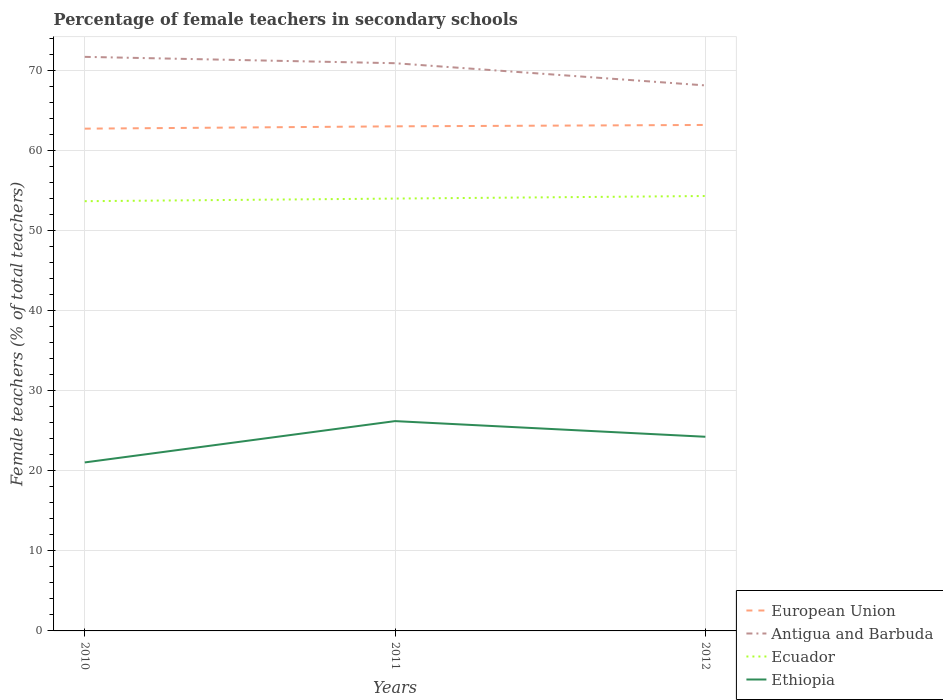Across all years, what is the maximum percentage of female teachers in Ecuador?
Make the answer very short. 53.72. In which year was the percentage of female teachers in Ecuador maximum?
Your answer should be compact. 2010. What is the total percentage of female teachers in Antigua and Barbuda in the graph?
Your answer should be very brief. 3.57. What is the difference between the highest and the second highest percentage of female teachers in European Union?
Offer a terse response. 0.46. What is the difference between the highest and the lowest percentage of female teachers in Ethiopia?
Your answer should be compact. 2. Is the percentage of female teachers in Antigua and Barbuda strictly greater than the percentage of female teachers in European Union over the years?
Ensure brevity in your answer.  No. Does the graph contain grids?
Offer a very short reply. Yes. Where does the legend appear in the graph?
Offer a very short reply. Bottom right. How many legend labels are there?
Offer a very short reply. 4. How are the legend labels stacked?
Keep it short and to the point. Vertical. What is the title of the graph?
Give a very brief answer. Percentage of female teachers in secondary schools. What is the label or title of the Y-axis?
Offer a terse response. Female teachers (% of total teachers). What is the Female teachers (% of total teachers) in European Union in 2010?
Make the answer very short. 62.78. What is the Female teachers (% of total teachers) of Antigua and Barbuda in 2010?
Give a very brief answer. 71.76. What is the Female teachers (% of total teachers) of Ecuador in 2010?
Your answer should be very brief. 53.72. What is the Female teachers (% of total teachers) of Ethiopia in 2010?
Ensure brevity in your answer.  21.06. What is the Female teachers (% of total teachers) in European Union in 2011?
Ensure brevity in your answer.  63.07. What is the Female teachers (% of total teachers) of Antigua and Barbuda in 2011?
Provide a succinct answer. 70.96. What is the Female teachers (% of total teachers) in Ecuador in 2011?
Your answer should be very brief. 54.04. What is the Female teachers (% of total teachers) of Ethiopia in 2011?
Make the answer very short. 26.23. What is the Female teachers (% of total teachers) in European Union in 2012?
Your answer should be very brief. 63.25. What is the Female teachers (% of total teachers) in Antigua and Barbuda in 2012?
Keep it short and to the point. 68.19. What is the Female teachers (% of total teachers) in Ecuador in 2012?
Offer a terse response. 54.36. What is the Female teachers (% of total teachers) in Ethiopia in 2012?
Ensure brevity in your answer.  24.27. Across all years, what is the maximum Female teachers (% of total teachers) of European Union?
Your answer should be very brief. 63.25. Across all years, what is the maximum Female teachers (% of total teachers) of Antigua and Barbuda?
Your answer should be very brief. 71.76. Across all years, what is the maximum Female teachers (% of total teachers) of Ecuador?
Offer a very short reply. 54.36. Across all years, what is the maximum Female teachers (% of total teachers) in Ethiopia?
Ensure brevity in your answer.  26.23. Across all years, what is the minimum Female teachers (% of total teachers) of European Union?
Offer a terse response. 62.78. Across all years, what is the minimum Female teachers (% of total teachers) in Antigua and Barbuda?
Ensure brevity in your answer.  68.19. Across all years, what is the minimum Female teachers (% of total teachers) of Ecuador?
Give a very brief answer. 53.72. Across all years, what is the minimum Female teachers (% of total teachers) in Ethiopia?
Your answer should be very brief. 21.06. What is the total Female teachers (% of total teachers) in European Union in the graph?
Your answer should be compact. 189.1. What is the total Female teachers (% of total teachers) in Antigua and Barbuda in the graph?
Make the answer very short. 210.91. What is the total Female teachers (% of total teachers) in Ecuador in the graph?
Your answer should be very brief. 162.12. What is the total Female teachers (% of total teachers) in Ethiopia in the graph?
Provide a short and direct response. 71.56. What is the difference between the Female teachers (% of total teachers) of European Union in 2010 and that in 2011?
Your answer should be compact. -0.29. What is the difference between the Female teachers (% of total teachers) of Antigua and Barbuda in 2010 and that in 2011?
Your answer should be compact. 0.79. What is the difference between the Female teachers (% of total teachers) in Ecuador in 2010 and that in 2011?
Your response must be concise. -0.33. What is the difference between the Female teachers (% of total teachers) of Ethiopia in 2010 and that in 2011?
Offer a terse response. -5.17. What is the difference between the Female teachers (% of total teachers) in European Union in 2010 and that in 2012?
Offer a terse response. -0.46. What is the difference between the Female teachers (% of total teachers) of Antigua and Barbuda in 2010 and that in 2012?
Your answer should be compact. 3.57. What is the difference between the Female teachers (% of total teachers) in Ecuador in 2010 and that in 2012?
Provide a succinct answer. -0.65. What is the difference between the Female teachers (% of total teachers) of Ethiopia in 2010 and that in 2012?
Make the answer very short. -3.21. What is the difference between the Female teachers (% of total teachers) of European Union in 2011 and that in 2012?
Give a very brief answer. -0.17. What is the difference between the Female teachers (% of total teachers) in Antigua and Barbuda in 2011 and that in 2012?
Your answer should be compact. 2.78. What is the difference between the Female teachers (% of total teachers) in Ecuador in 2011 and that in 2012?
Keep it short and to the point. -0.32. What is the difference between the Female teachers (% of total teachers) of Ethiopia in 2011 and that in 2012?
Provide a short and direct response. 1.96. What is the difference between the Female teachers (% of total teachers) in European Union in 2010 and the Female teachers (% of total teachers) in Antigua and Barbuda in 2011?
Give a very brief answer. -8.18. What is the difference between the Female teachers (% of total teachers) in European Union in 2010 and the Female teachers (% of total teachers) in Ecuador in 2011?
Offer a terse response. 8.74. What is the difference between the Female teachers (% of total teachers) in European Union in 2010 and the Female teachers (% of total teachers) in Ethiopia in 2011?
Make the answer very short. 36.56. What is the difference between the Female teachers (% of total teachers) in Antigua and Barbuda in 2010 and the Female teachers (% of total teachers) in Ecuador in 2011?
Your answer should be compact. 17.71. What is the difference between the Female teachers (% of total teachers) in Antigua and Barbuda in 2010 and the Female teachers (% of total teachers) in Ethiopia in 2011?
Provide a succinct answer. 45.53. What is the difference between the Female teachers (% of total teachers) in Ecuador in 2010 and the Female teachers (% of total teachers) in Ethiopia in 2011?
Keep it short and to the point. 27.49. What is the difference between the Female teachers (% of total teachers) in European Union in 2010 and the Female teachers (% of total teachers) in Antigua and Barbuda in 2012?
Provide a succinct answer. -5.41. What is the difference between the Female teachers (% of total teachers) of European Union in 2010 and the Female teachers (% of total teachers) of Ecuador in 2012?
Ensure brevity in your answer.  8.42. What is the difference between the Female teachers (% of total teachers) of European Union in 2010 and the Female teachers (% of total teachers) of Ethiopia in 2012?
Offer a terse response. 38.51. What is the difference between the Female teachers (% of total teachers) of Antigua and Barbuda in 2010 and the Female teachers (% of total teachers) of Ecuador in 2012?
Ensure brevity in your answer.  17.39. What is the difference between the Female teachers (% of total teachers) in Antigua and Barbuda in 2010 and the Female teachers (% of total teachers) in Ethiopia in 2012?
Provide a short and direct response. 47.49. What is the difference between the Female teachers (% of total teachers) of Ecuador in 2010 and the Female teachers (% of total teachers) of Ethiopia in 2012?
Provide a succinct answer. 29.45. What is the difference between the Female teachers (% of total teachers) in European Union in 2011 and the Female teachers (% of total teachers) in Antigua and Barbuda in 2012?
Give a very brief answer. -5.12. What is the difference between the Female teachers (% of total teachers) in European Union in 2011 and the Female teachers (% of total teachers) in Ecuador in 2012?
Make the answer very short. 8.71. What is the difference between the Female teachers (% of total teachers) of European Union in 2011 and the Female teachers (% of total teachers) of Ethiopia in 2012?
Provide a short and direct response. 38.8. What is the difference between the Female teachers (% of total teachers) in Antigua and Barbuda in 2011 and the Female teachers (% of total teachers) in Ecuador in 2012?
Your answer should be very brief. 16.6. What is the difference between the Female teachers (% of total teachers) in Antigua and Barbuda in 2011 and the Female teachers (% of total teachers) in Ethiopia in 2012?
Give a very brief answer. 46.69. What is the difference between the Female teachers (% of total teachers) in Ecuador in 2011 and the Female teachers (% of total teachers) in Ethiopia in 2012?
Offer a terse response. 29.77. What is the average Female teachers (% of total teachers) in European Union per year?
Your response must be concise. 63.03. What is the average Female teachers (% of total teachers) of Antigua and Barbuda per year?
Ensure brevity in your answer.  70.3. What is the average Female teachers (% of total teachers) of Ecuador per year?
Keep it short and to the point. 54.04. What is the average Female teachers (% of total teachers) in Ethiopia per year?
Your response must be concise. 23.85. In the year 2010, what is the difference between the Female teachers (% of total teachers) of European Union and Female teachers (% of total teachers) of Antigua and Barbuda?
Ensure brevity in your answer.  -8.98. In the year 2010, what is the difference between the Female teachers (% of total teachers) in European Union and Female teachers (% of total teachers) in Ecuador?
Your answer should be compact. 9.07. In the year 2010, what is the difference between the Female teachers (% of total teachers) of European Union and Female teachers (% of total teachers) of Ethiopia?
Give a very brief answer. 41.72. In the year 2010, what is the difference between the Female teachers (% of total teachers) in Antigua and Barbuda and Female teachers (% of total teachers) in Ecuador?
Offer a very short reply. 18.04. In the year 2010, what is the difference between the Female teachers (% of total teachers) of Antigua and Barbuda and Female teachers (% of total teachers) of Ethiopia?
Offer a terse response. 50.7. In the year 2010, what is the difference between the Female teachers (% of total teachers) in Ecuador and Female teachers (% of total teachers) in Ethiopia?
Your response must be concise. 32.65. In the year 2011, what is the difference between the Female teachers (% of total teachers) in European Union and Female teachers (% of total teachers) in Antigua and Barbuda?
Make the answer very short. -7.89. In the year 2011, what is the difference between the Female teachers (% of total teachers) in European Union and Female teachers (% of total teachers) in Ecuador?
Your answer should be very brief. 9.03. In the year 2011, what is the difference between the Female teachers (% of total teachers) in European Union and Female teachers (% of total teachers) in Ethiopia?
Offer a very short reply. 36.85. In the year 2011, what is the difference between the Female teachers (% of total teachers) in Antigua and Barbuda and Female teachers (% of total teachers) in Ecuador?
Offer a terse response. 16.92. In the year 2011, what is the difference between the Female teachers (% of total teachers) of Antigua and Barbuda and Female teachers (% of total teachers) of Ethiopia?
Provide a short and direct response. 44.74. In the year 2011, what is the difference between the Female teachers (% of total teachers) in Ecuador and Female teachers (% of total teachers) in Ethiopia?
Your answer should be very brief. 27.82. In the year 2012, what is the difference between the Female teachers (% of total teachers) in European Union and Female teachers (% of total teachers) in Antigua and Barbuda?
Make the answer very short. -4.94. In the year 2012, what is the difference between the Female teachers (% of total teachers) of European Union and Female teachers (% of total teachers) of Ecuador?
Your answer should be compact. 8.88. In the year 2012, what is the difference between the Female teachers (% of total teachers) of European Union and Female teachers (% of total teachers) of Ethiopia?
Ensure brevity in your answer.  38.98. In the year 2012, what is the difference between the Female teachers (% of total teachers) of Antigua and Barbuda and Female teachers (% of total teachers) of Ecuador?
Keep it short and to the point. 13.82. In the year 2012, what is the difference between the Female teachers (% of total teachers) of Antigua and Barbuda and Female teachers (% of total teachers) of Ethiopia?
Provide a succinct answer. 43.92. In the year 2012, what is the difference between the Female teachers (% of total teachers) in Ecuador and Female teachers (% of total teachers) in Ethiopia?
Your answer should be compact. 30.09. What is the ratio of the Female teachers (% of total teachers) in European Union in 2010 to that in 2011?
Offer a very short reply. 1. What is the ratio of the Female teachers (% of total teachers) of Antigua and Barbuda in 2010 to that in 2011?
Your answer should be very brief. 1.01. What is the ratio of the Female teachers (% of total teachers) in Ethiopia in 2010 to that in 2011?
Give a very brief answer. 0.8. What is the ratio of the Female teachers (% of total teachers) of European Union in 2010 to that in 2012?
Your answer should be compact. 0.99. What is the ratio of the Female teachers (% of total teachers) in Antigua and Barbuda in 2010 to that in 2012?
Your response must be concise. 1.05. What is the ratio of the Female teachers (% of total teachers) of Ethiopia in 2010 to that in 2012?
Provide a succinct answer. 0.87. What is the ratio of the Female teachers (% of total teachers) in European Union in 2011 to that in 2012?
Your response must be concise. 1. What is the ratio of the Female teachers (% of total teachers) of Antigua and Barbuda in 2011 to that in 2012?
Your answer should be compact. 1.04. What is the ratio of the Female teachers (% of total teachers) of Ecuador in 2011 to that in 2012?
Your answer should be very brief. 0.99. What is the ratio of the Female teachers (% of total teachers) in Ethiopia in 2011 to that in 2012?
Offer a terse response. 1.08. What is the difference between the highest and the second highest Female teachers (% of total teachers) in European Union?
Your answer should be compact. 0.17. What is the difference between the highest and the second highest Female teachers (% of total teachers) of Antigua and Barbuda?
Give a very brief answer. 0.79. What is the difference between the highest and the second highest Female teachers (% of total teachers) in Ecuador?
Offer a terse response. 0.32. What is the difference between the highest and the second highest Female teachers (% of total teachers) in Ethiopia?
Offer a terse response. 1.96. What is the difference between the highest and the lowest Female teachers (% of total teachers) in European Union?
Give a very brief answer. 0.46. What is the difference between the highest and the lowest Female teachers (% of total teachers) of Antigua and Barbuda?
Provide a short and direct response. 3.57. What is the difference between the highest and the lowest Female teachers (% of total teachers) in Ecuador?
Give a very brief answer. 0.65. What is the difference between the highest and the lowest Female teachers (% of total teachers) of Ethiopia?
Make the answer very short. 5.17. 